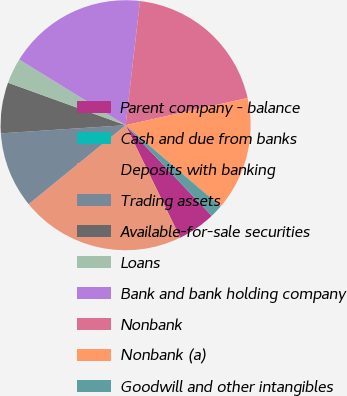<chart> <loc_0><loc_0><loc_500><loc_500><pie_chart><fcel>Parent company - balance<fcel>Cash and due from banks<fcel>Deposits with banking<fcel>Trading assets<fcel>Available-for-sale securities<fcel>Loans<fcel>Bank and bank holding company<fcel>Nonbank<fcel>Nonbank (a)<fcel>Goodwill and other intangibles<nl><fcel>4.92%<fcel>0.0%<fcel>21.31%<fcel>9.84%<fcel>6.56%<fcel>3.28%<fcel>18.03%<fcel>19.67%<fcel>14.75%<fcel>1.64%<nl></chart> 